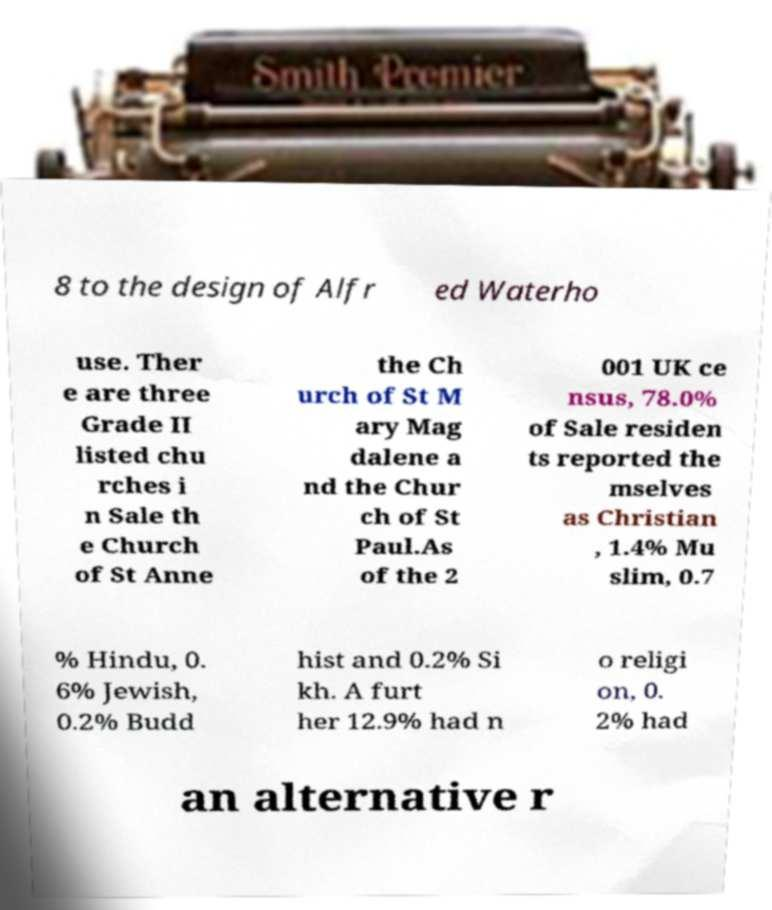I need the written content from this picture converted into text. Can you do that? 8 to the design of Alfr ed Waterho use. Ther e are three Grade II listed chu rches i n Sale th e Church of St Anne the Ch urch of St M ary Mag dalene a nd the Chur ch of St Paul.As of the 2 001 UK ce nsus, 78.0% of Sale residen ts reported the mselves as Christian , 1.4% Mu slim, 0.7 % Hindu, 0. 6% Jewish, 0.2% Budd hist and 0.2% Si kh. A furt her 12.9% had n o religi on, 0. 2% had an alternative r 